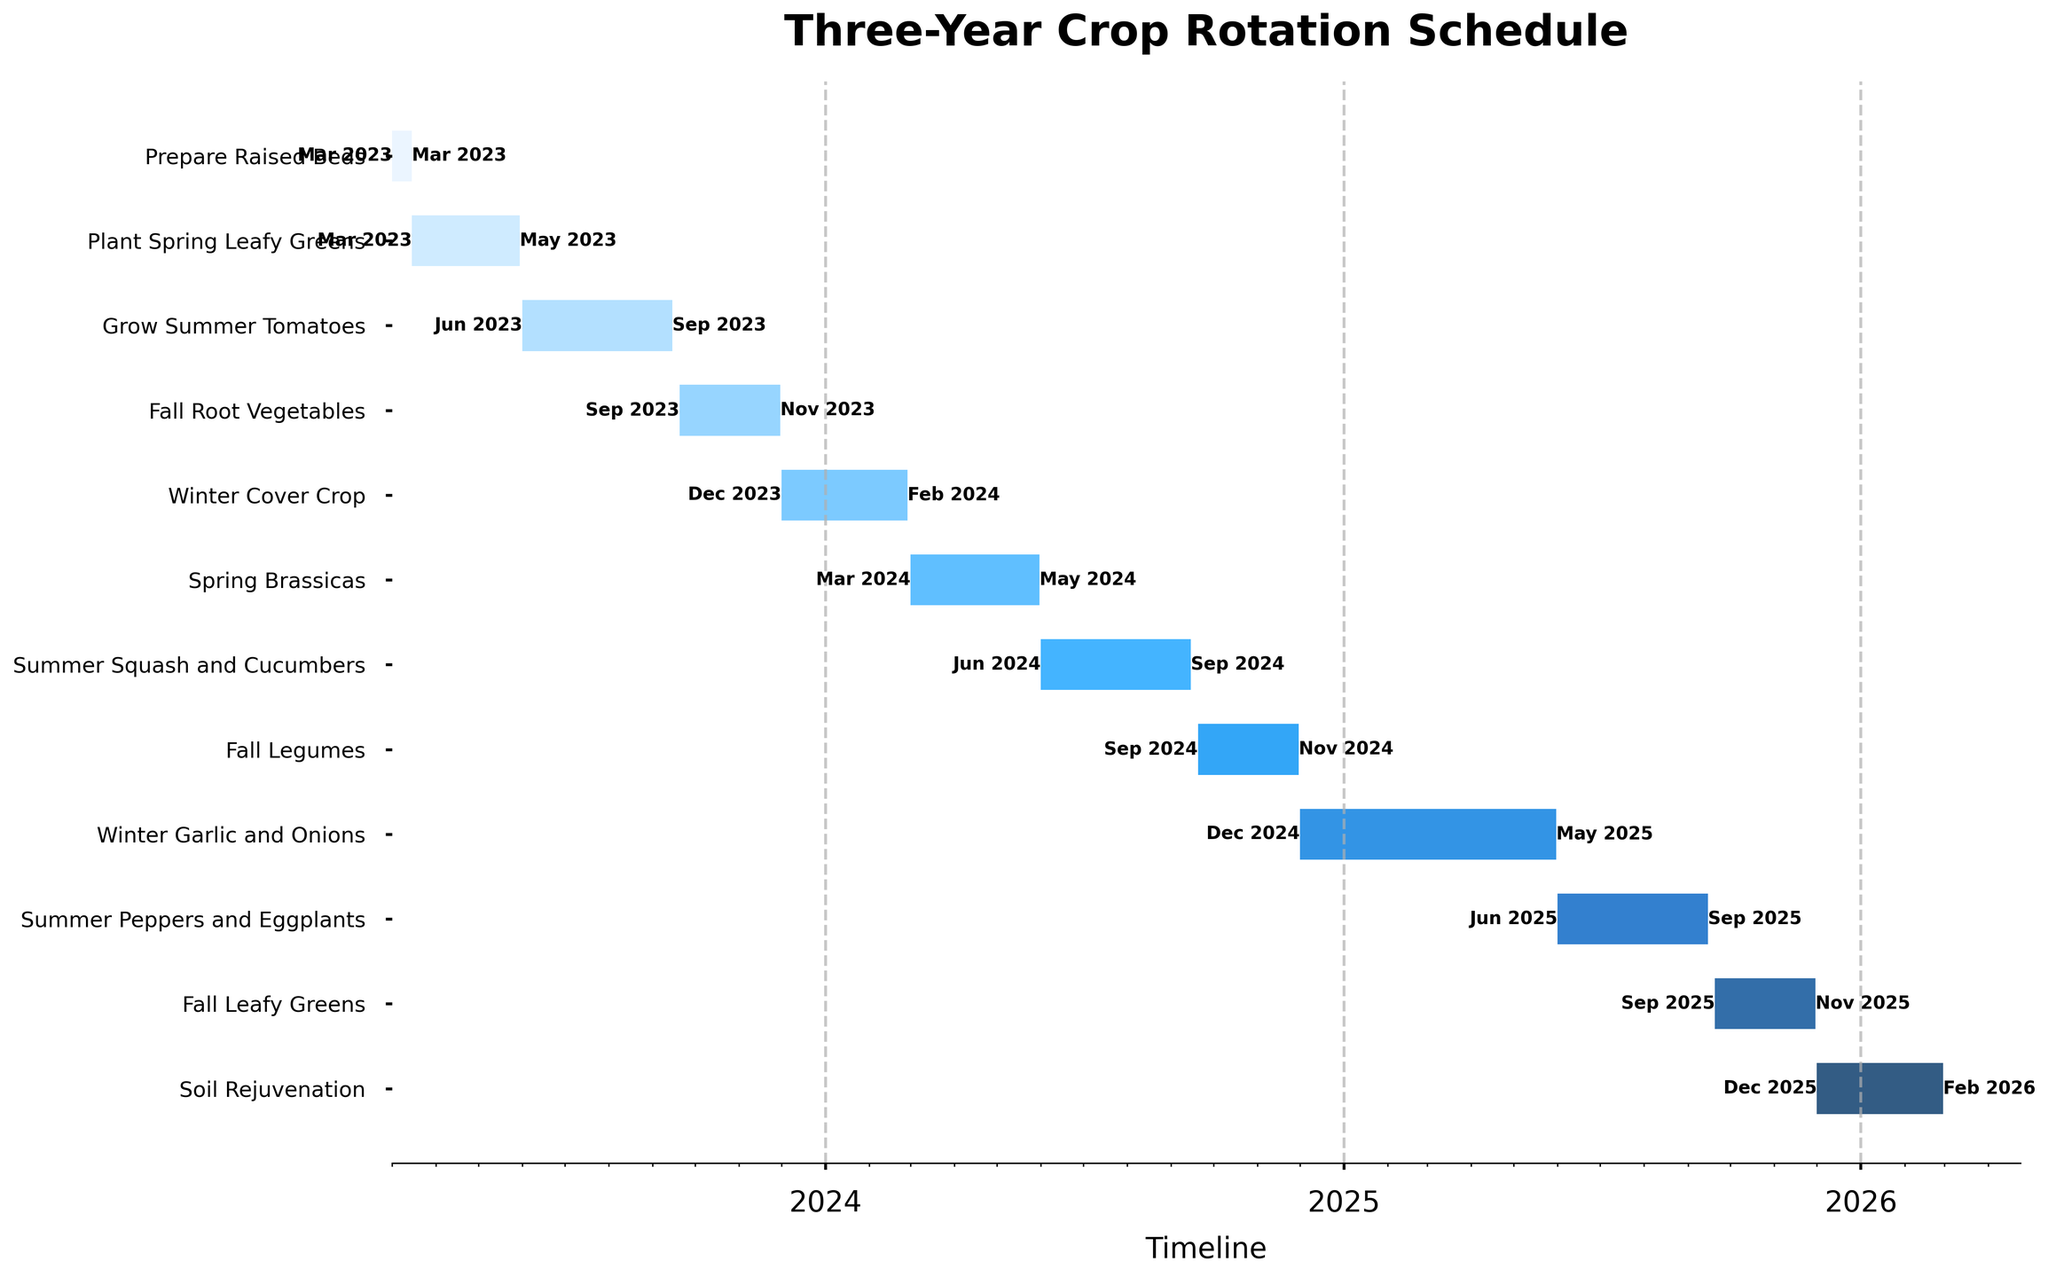Which task marks the beginning of the crop rotation schedule? The beginning of the schedule can be identified by looking at the first task on the timeline. "Prepare Raised Beds" is the initial task starting in March 2023.
Answer: Prepare Raised Beds How long is the duration for growing the Winter Cover Crop? To find the duration, calculate the difference between the start and end dates of the Winter Cover Crop. From Dec 01, 2023 to Feb 28, 2024, the duration is 90 days.
Answer: 90 days During which season is the task "Fall Root Vegetables" scheduled? The season for a task can be identified by its name and dates. "Fall Root Vegetables" is scheduled from September to November, which falls under fall.
Answer: Fall Which tasks are carried out during the summer months in 2024? Look for tasks scheduled between June and September 2024. "Summer Squash and Cucumbers" is the task during this timeframe.
Answer: Summer Squash and Cucumbers What are the start and end dates for the task "Spring Brassicas"? The start and end dates for a task can be found by locating the corresponding bar on the chart. "Spring Brassicas" starts on March 01, 2024 and ends on May 31, 2024.
Answer: March 01, 2024 to May 31, 2024 How many tasks are planned for the year 2025? Count the number of tasks with start dates within the year 2025. There are three tasks: "Winter Garlic and Onions," "Summer Peppers and Eggplants," and "Fall Leafy Greens."
Answer: 3 tasks Which task has the longest duration? Compare the duration of all tasks by looking at the length of the bars. "Winter Garlic and Onions" has the longest duration from Dec 01, 2024 to May 31, 2025.
Answer: Winter Garlic and Onions How does the time frame of "Fall Leafy Greens" compare to "Fall Legumes"? Compare the start and end dates of the two tasks. "Fall Leafy Greens" is from Sep 20, 2025 to Nov 30, 2025, while "Fall Legumes" is from Sep 20, 2024 to Nov 30, 2024. Both tasks occur in the same timeframe but in different years.
Answer: Same timeframe, different years When does the task "Soil Rejuvenation" occur? Find the "Soil Rejuvenation" task on the chart to identify its start and end dates. It occurs from Dec 01, 2025 to Feb 28, 2026.
Answer: December 2025 to February 2026 How many tasks overlap in the month of September 2024? Identify tasks that include September 2024 within their date range. The overlapping tasks are "Summer Squash and Cucumbers" (until Sep 15) and "Fall Legumes" (starting Sep 20).
Answer: 2 tasks 